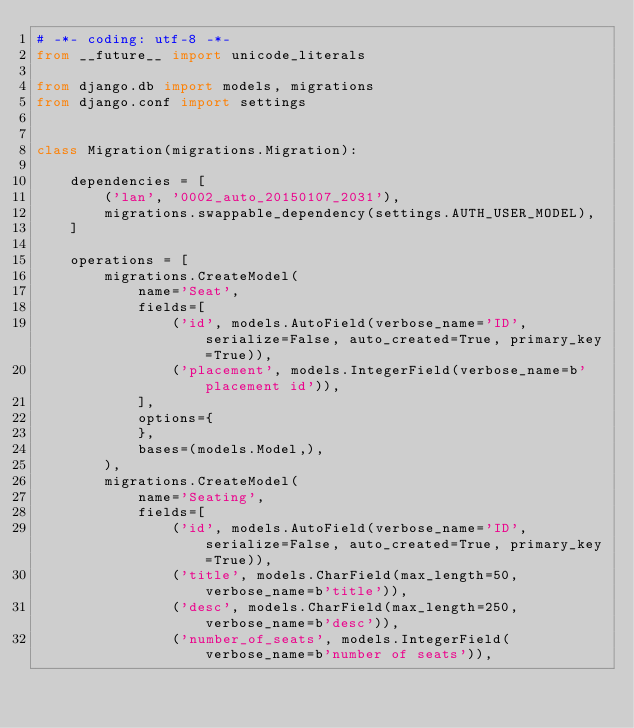<code> <loc_0><loc_0><loc_500><loc_500><_Python_># -*- coding: utf-8 -*-
from __future__ import unicode_literals

from django.db import models, migrations
from django.conf import settings


class Migration(migrations.Migration):

    dependencies = [
        ('lan', '0002_auto_20150107_2031'),
        migrations.swappable_dependency(settings.AUTH_USER_MODEL),
    ]

    operations = [
        migrations.CreateModel(
            name='Seat',
            fields=[
                ('id', models.AutoField(verbose_name='ID', serialize=False, auto_created=True, primary_key=True)),
                ('placement', models.IntegerField(verbose_name=b'placement id')),
            ],
            options={
            },
            bases=(models.Model,),
        ),
        migrations.CreateModel(
            name='Seating',
            fields=[
                ('id', models.AutoField(verbose_name='ID', serialize=False, auto_created=True, primary_key=True)),
                ('title', models.CharField(max_length=50, verbose_name=b'title')),
                ('desc', models.CharField(max_length=250, verbose_name=b'desc')),
                ('number_of_seats', models.IntegerField(verbose_name=b'number of seats')),</code> 